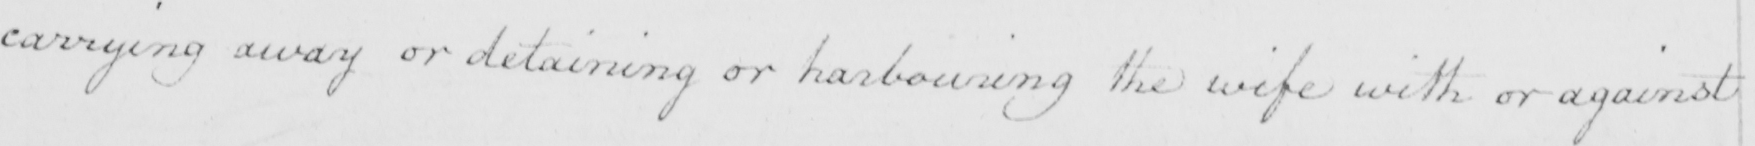What text is written in this handwritten line? carrying away or detaining or harbouring the wife with or against 